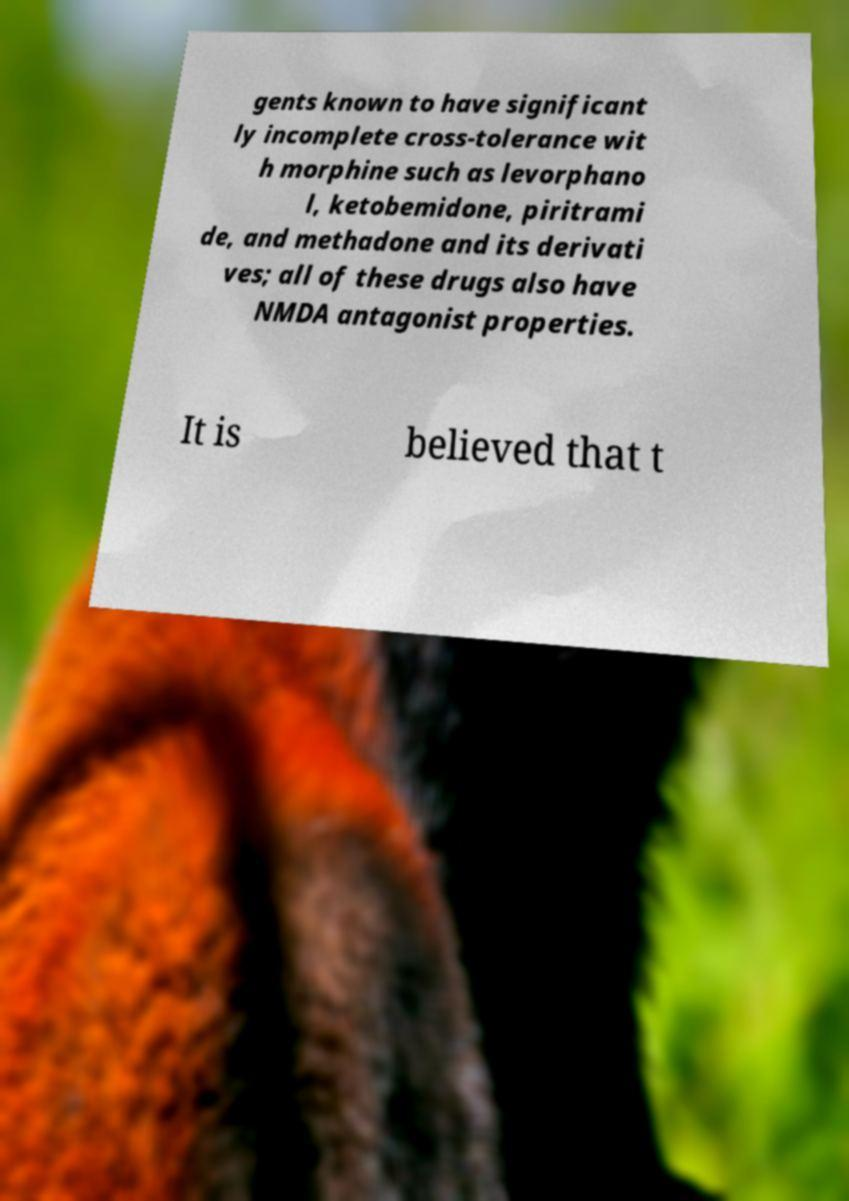What messages or text are displayed in this image? I need them in a readable, typed format. gents known to have significant ly incomplete cross-tolerance wit h morphine such as levorphano l, ketobemidone, piritrami de, and methadone and its derivati ves; all of these drugs also have NMDA antagonist properties. It is believed that t 